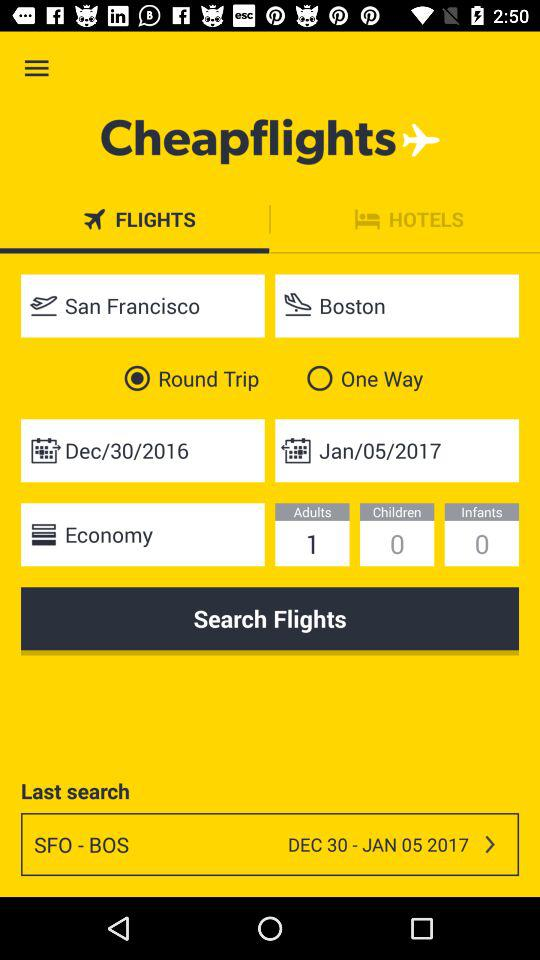How many more days are there between the departure and return dates?
Answer the question using a single word or phrase. 5 